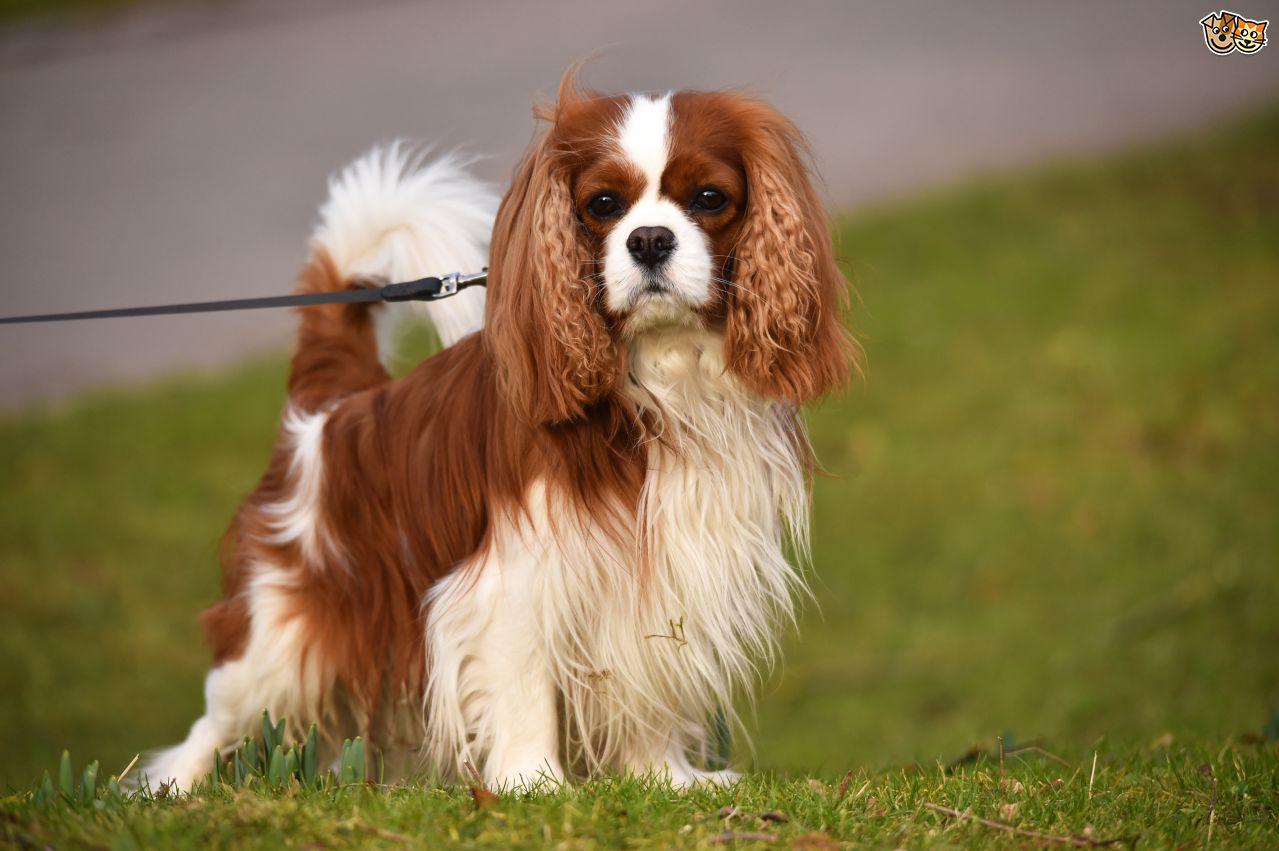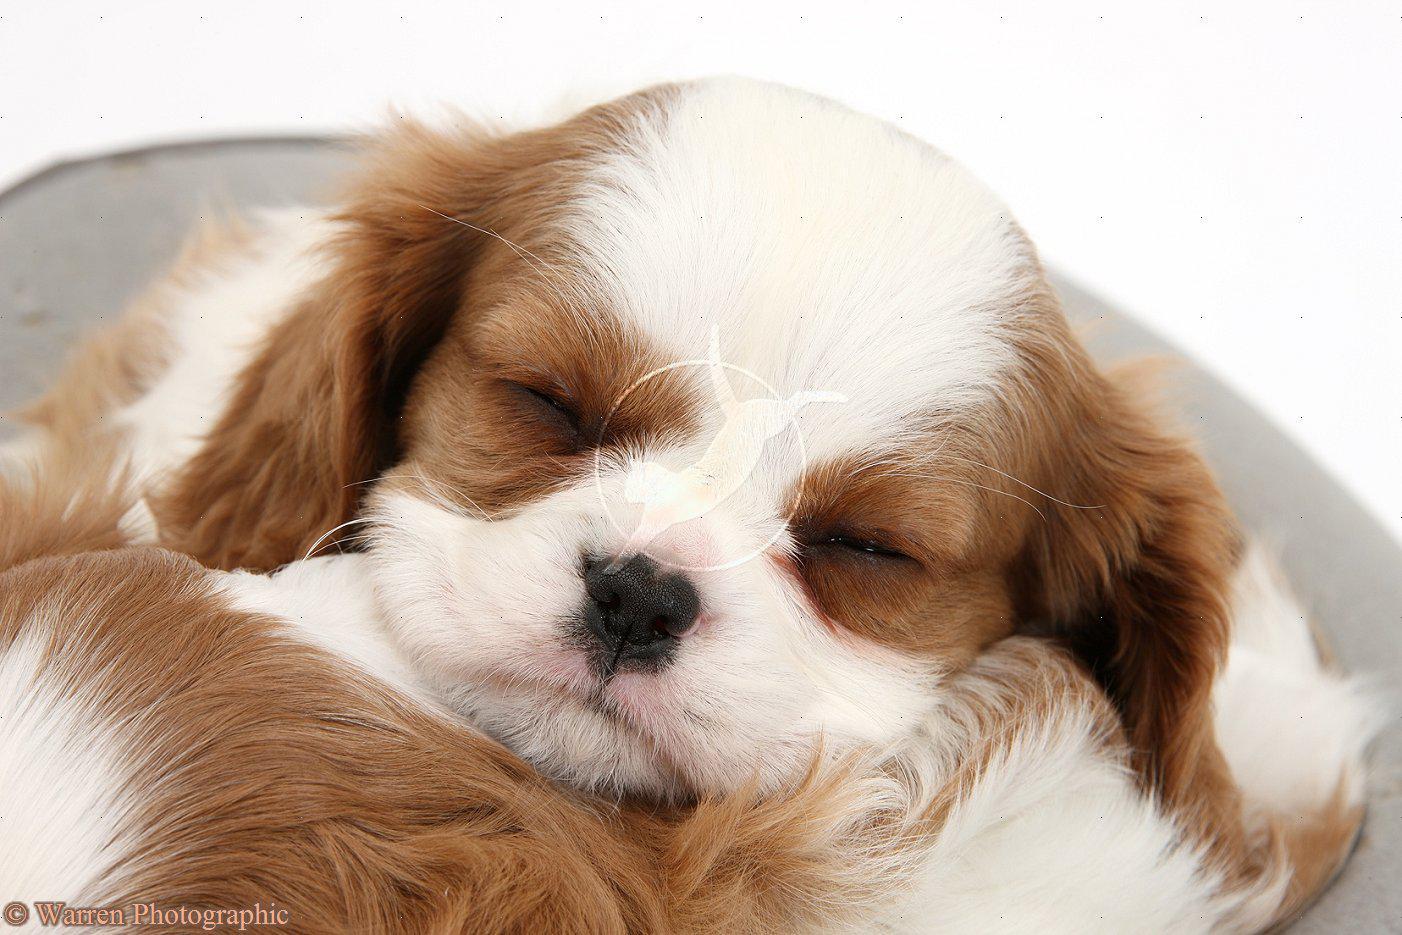The first image is the image on the left, the second image is the image on the right. Analyze the images presented: Is the assertion "Two animals, including at least one spaniel dog, pose side-by-side in one image." valid? Answer yes or no. No. 